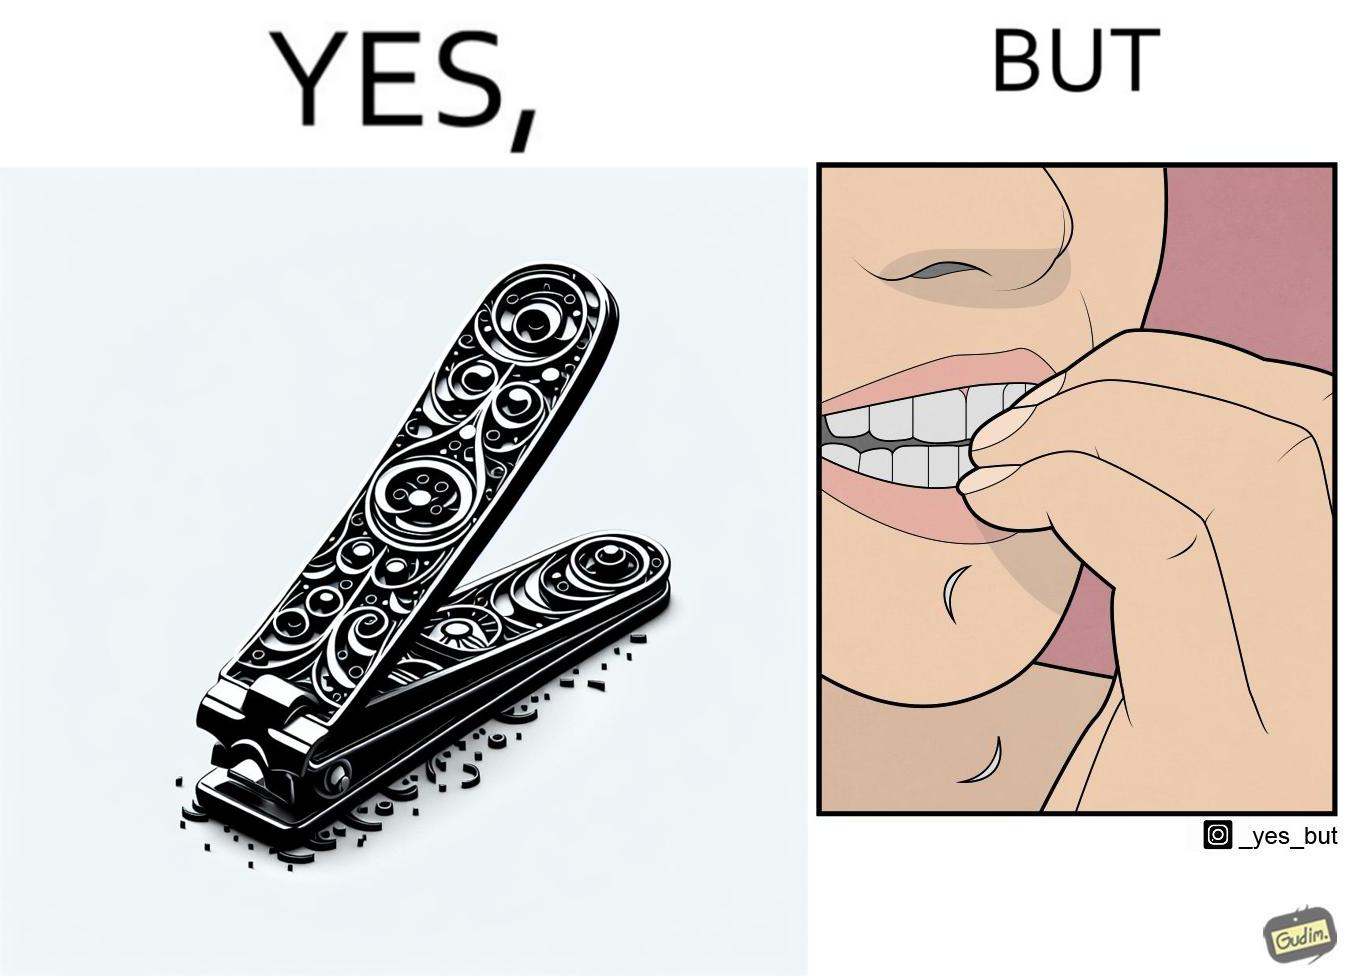Does this image contain satire or humor? Yes, this image is satirical. 